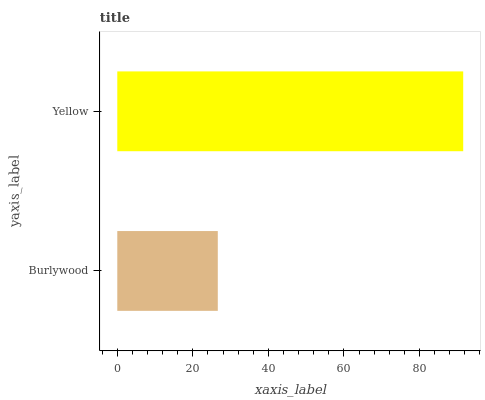Is Burlywood the minimum?
Answer yes or no. Yes. Is Yellow the maximum?
Answer yes or no. Yes. Is Yellow the minimum?
Answer yes or no. No. Is Yellow greater than Burlywood?
Answer yes or no. Yes. Is Burlywood less than Yellow?
Answer yes or no. Yes. Is Burlywood greater than Yellow?
Answer yes or no. No. Is Yellow less than Burlywood?
Answer yes or no. No. Is Yellow the high median?
Answer yes or no. Yes. Is Burlywood the low median?
Answer yes or no. Yes. Is Burlywood the high median?
Answer yes or no. No. Is Yellow the low median?
Answer yes or no. No. 